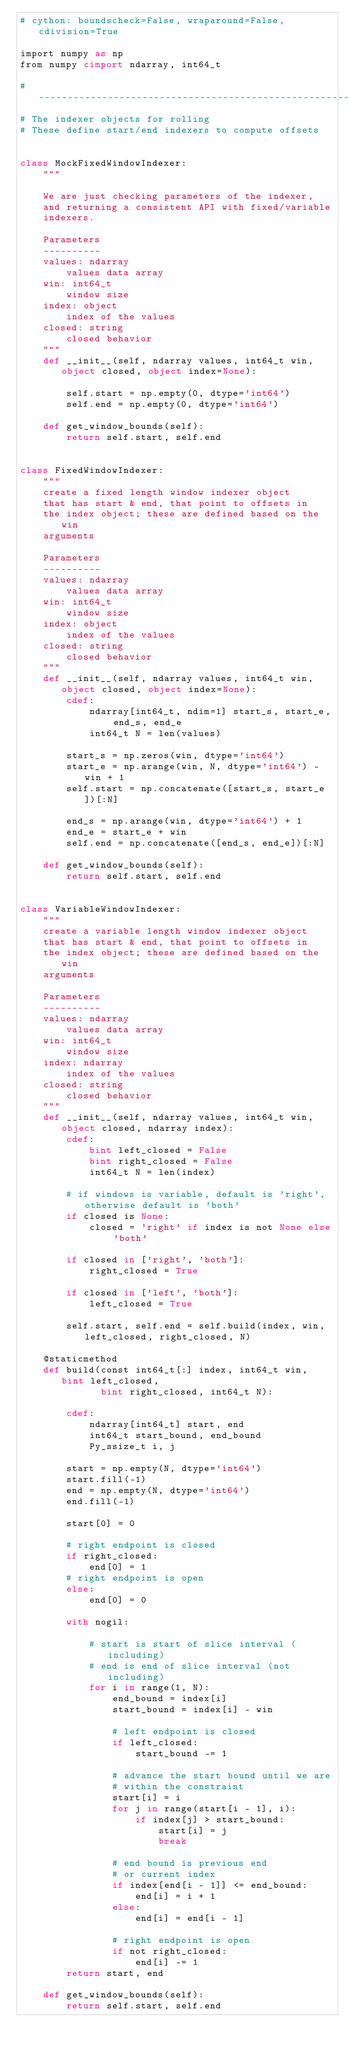Convert code to text. <code><loc_0><loc_0><loc_500><loc_500><_Cython_># cython: boundscheck=False, wraparound=False, cdivision=True

import numpy as np
from numpy cimport ndarray, int64_t

# ----------------------------------------------------------------------
# The indexer objects for rolling
# These define start/end indexers to compute offsets


class MockFixedWindowIndexer:
    """

    We are just checking parameters of the indexer,
    and returning a consistent API with fixed/variable
    indexers.

    Parameters
    ----------
    values: ndarray
        values data array
    win: int64_t
        window size
    index: object
        index of the values
    closed: string
        closed behavior
    """
    def __init__(self, ndarray values, int64_t win, object closed, object index=None):

        self.start = np.empty(0, dtype='int64')
        self.end = np.empty(0, dtype='int64')

    def get_window_bounds(self):
        return self.start, self.end


class FixedWindowIndexer:
    """
    create a fixed length window indexer object
    that has start & end, that point to offsets in
    the index object; these are defined based on the win
    arguments

    Parameters
    ----------
    values: ndarray
        values data array
    win: int64_t
        window size
    index: object
        index of the values
    closed: string
        closed behavior
    """
    def __init__(self, ndarray values, int64_t win, object closed, object index=None):
        cdef:
            ndarray[int64_t, ndim=1] start_s, start_e, end_s, end_e
            int64_t N = len(values)

        start_s = np.zeros(win, dtype='int64')
        start_e = np.arange(win, N, dtype='int64') - win + 1
        self.start = np.concatenate([start_s, start_e])[:N]

        end_s = np.arange(win, dtype='int64') + 1
        end_e = start_e + win
        self.end = np.concatenate([end_s, end_e])[:N]

    def get_window_bounds(self):
        return self.start, self.end


class VariableWindowIndexer:
    """
    create a variable length window indexer object
    that has start & end, that point to offsets in
    the index object; these are defined based on the win
    arguments

    Parameters
    ----------
    values: ndarray
        values data array
    win: int64_t
        window size
    index: ndarray
        index of the values
    closed: string
        closed behavior
    """
    def __init__(self, ndarray values, int64_t win, object closed, ndarray index):
        cdef:
            bint left_closed = False
            bint right_closed = False
            int64_t N = len(index)

        # if windows is variable, default is 'right', otherwise default is 'both'
        if closed is None:
            closed = 'right' if index is not None else 'both'

        if closed in ['right', 'both']:
            right_closed = True

        if closed in ['left', 'both']:
            left_closed = True

        self.start, self.end = self.build(index, win, left_closed, right_closed, N)

    @staticmethod
    def build(const int64_t[:] index, int64_t win, bint left_closed,
              bint right_closed, int64_t N):

        cdef:
            ndarray[int64_t] start, end
            int64_t start_bound, end_bound
            Py_ssize_t i, j

        start = np.empty(N, dtype='int64')
        start.fill(-1)
        end = np.empty(N, dtype='int64')
        end.fill(-1)

        start[0] = 0

        # right endpoint is closed
        if right_closed:
            end[0] = 1
        # right endpoint is open
        else:
            end[0] = 0

        with nogil:

            # start is start of slice interval (including)
            # end is end of slice interval (not including)
            for i in range(1, N):
                end_bound = index[i]
                start_bound = index[i] - win

                # left endpoint is closed
                if left_closed:
                    start_bound -= 1

                # advance the start bound until we are
                # within the constraint
                start[i] = i
                for j in range(start[i - 1], i):
                    if index[j] > start_bound:
                        start[i] = j
                        break

                # end bound is previous end
                # or current index
                if index[end[i - 1]] <= end_bound:
                    end[i] = i + 1
                else:
                    end[i] = end[i - 1]

                # right endpoint is open
                if not right_closed:
                    end[i] -= 1
        return start, end

    def get_window_bounds(self):
        return self.start, self.end
</code> 